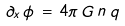<formula> <loc_0><loc_0><loc_500><loc_500>\partial _ { x } \, \phi \, = \, 4 \pi \, G \, n \, q</formula> 